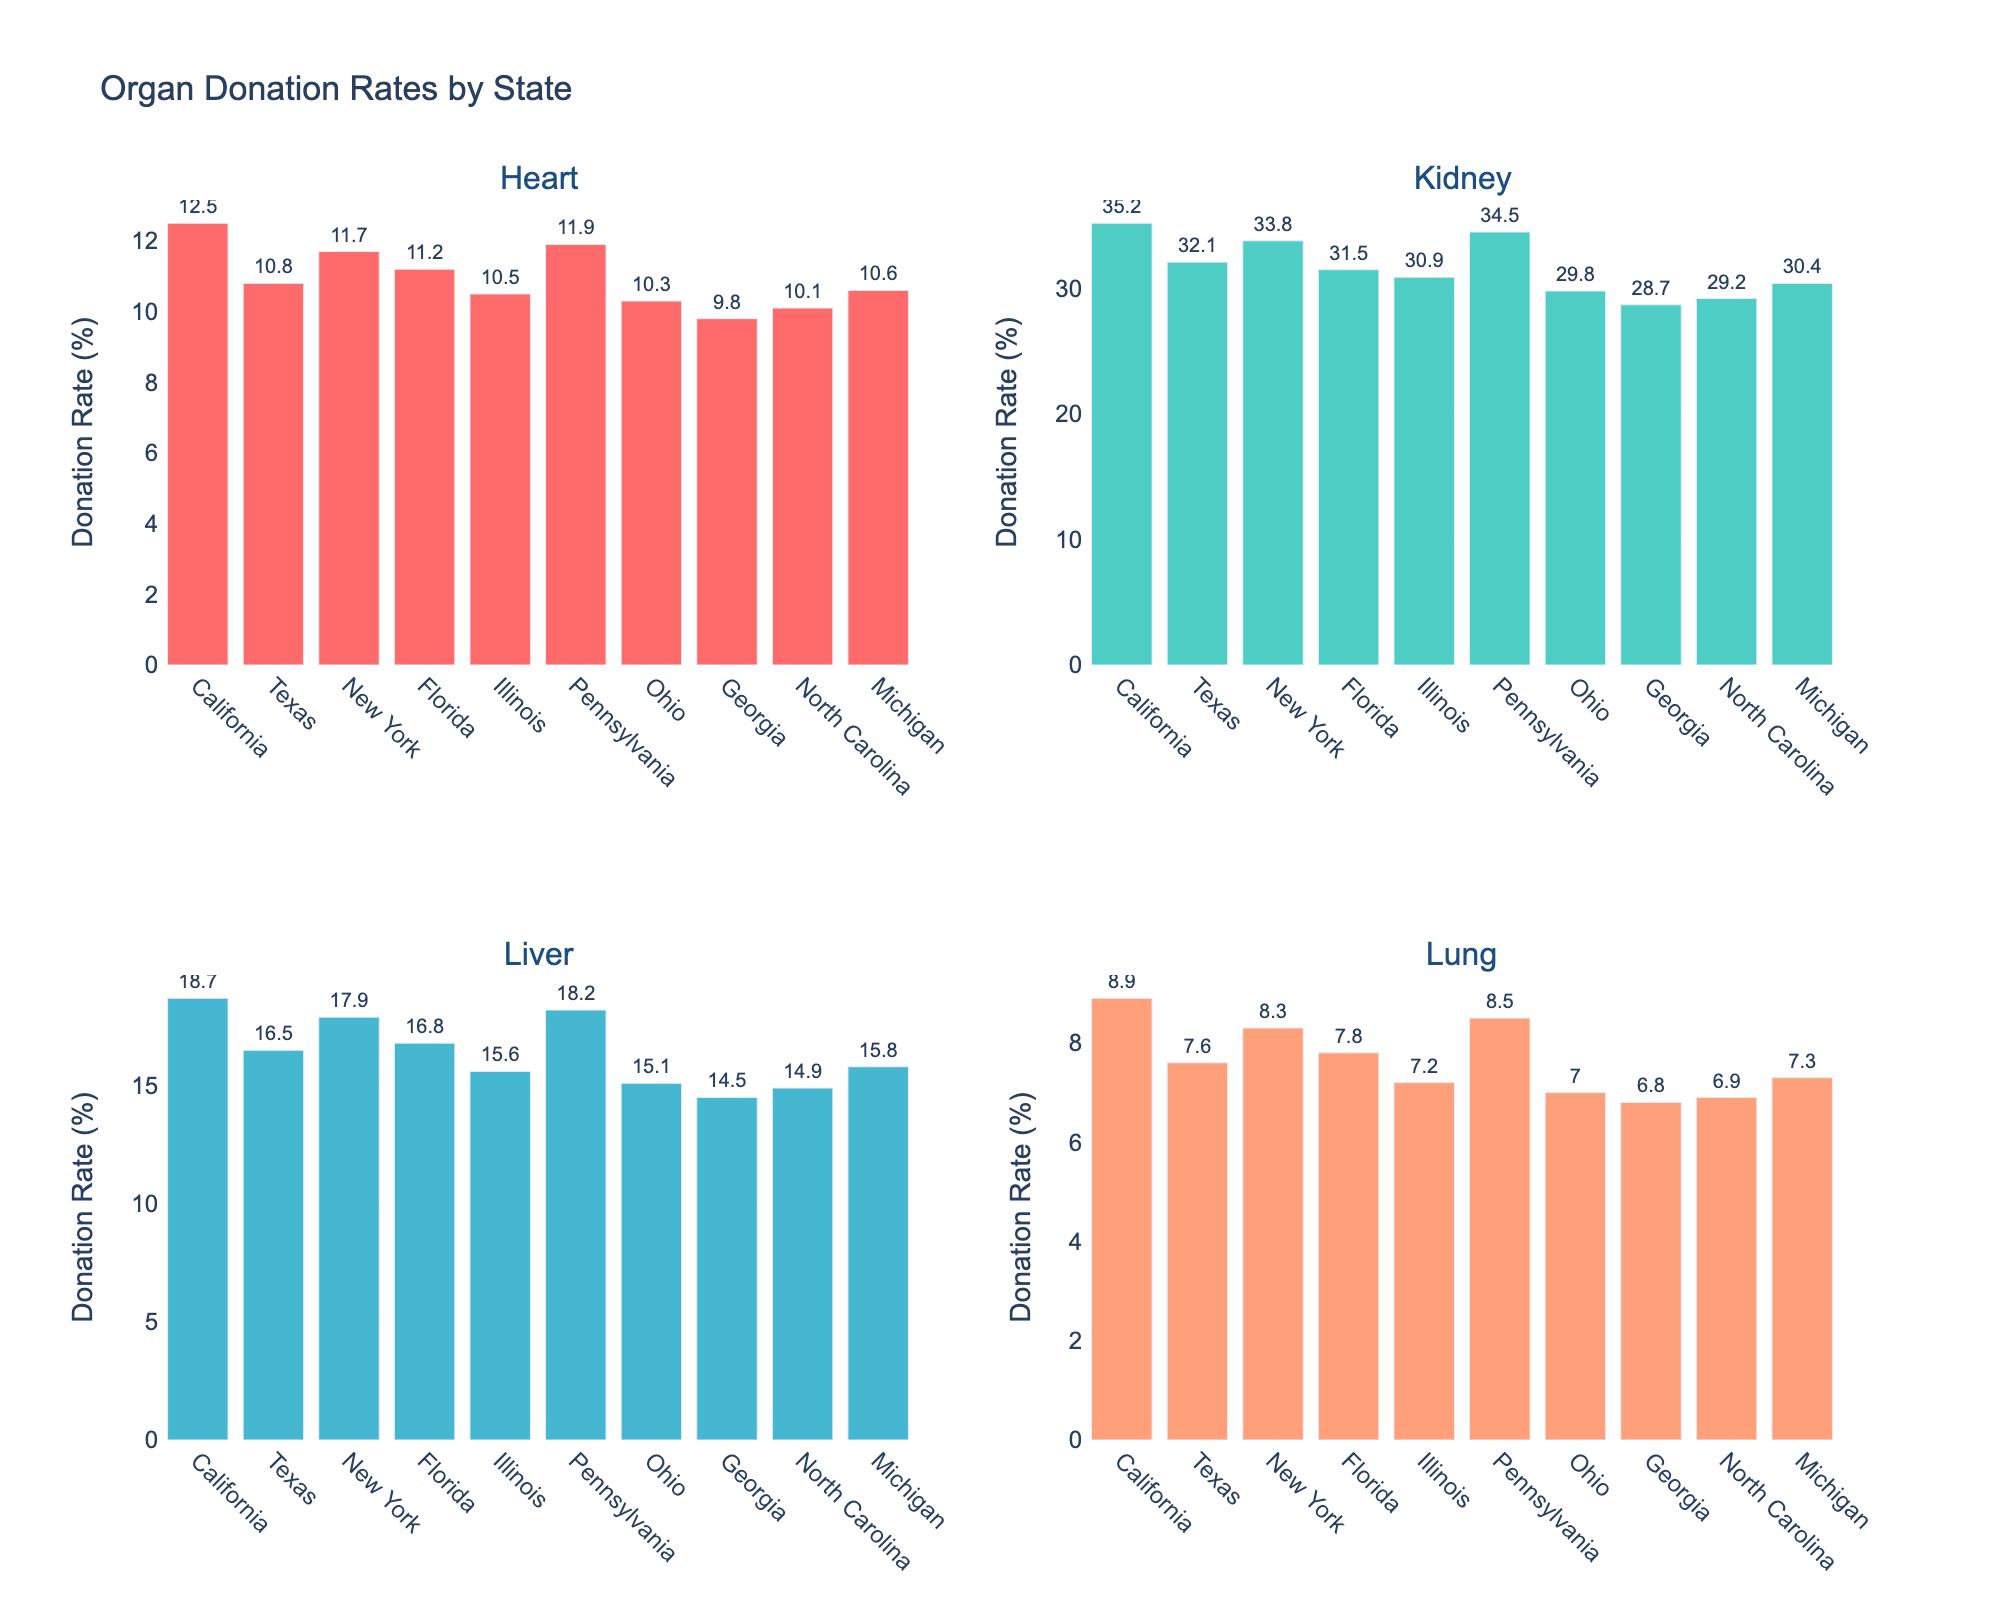What is the title of the figure? The title is usually displayed at the top of the figure. It is clearly indicated as "Attendance Trends at Major Civil Rights Rallies (1950s to Present)"
Answer: Attendance Trends at Major Civil Rights Rallies (1950s to Present) Which cause had the highest attendance in 2020? By looking at the y-values for the year 2020 across all subplots, it's apparent that the LGBTQ+ Rights rally had the highest attendance with a peak reaching 2,000,000
Answer: LGBTQ+ Rights How many causes are displayed in the figure? The figure is divided into four subplots, each representing a different cause: Civil Rights, Women's Rights, LGBTQ+ Rights, and Environmental Justice
Answer: Four What is the attendance trend for Civil Rights rallies from 1955 to 2020? By examining the plot for Civil Rights, we see that attendance starts at 20,000 in 1955, peaks at 250,000 in 1963, fluctuates over the years, and then rises steeply to 500,000 in 2020
Answer: Rapid increase then fluctuation Compare the attendance of Women's Rights rallies in 1975 and 2020. By observing the values on the y-axis for Women's Rights in both 1975 and 2020, it's clear that attendance was 100,000 in 1975 and significantly increased to 3,000,000 in 2020
Answer: Increased from 100,000 to 3,000,000 Which year had the lowest attendance for Environmental Justice rallies? By checking the lowest y-values in the Environmental Justice subplot, it's apparent that the year 1955 had the lowest attendance with just 500 attendees
Answer: 1955 In which cause did the attendance see a consistent and significant increase over the years? Analyzing all the subplots, we observe that the Women's Rights cause shows a consistent and significant increase, especially evident from 1975 onwards
Answer: Women's Rights How does the attendance of LGBTQ+ Rights rallies in 2000 compare to Civil Rights rallies in the same year? In the subplots, LGBTQ+ Rights in 2000 had 750,000 attendees, whereas Civil Rights had 100,000 attendees, indicating that LGBTQ+ Rights rallies had a significantly higher attendance that year
Answer: LGBTQ+ Rights had higher attendance What is the average attendance for Women's Rights rallies from 1993 to 2020? Summing the attendance values for the years 1993, 2000, 2008, 2015, and 2020 (80,000 + 500,000 + 750,000 + 1,000,000 + 3,000,000) gives 5,330,000. Dividing by the number of years (5) results in an average attendance of 1,066,000
Answer: 1,066,000 What are the maximum attendances recorded for each cause, and which year did they occur? By identifying the highest points in each subplot: Civil Rights (500,000 in 2020), Women's Rights (3,000,000 in 2020), LGBTQ+ Rights (2,000,000 in 2020), Environmental Justice (1,000,000 in 2020)
Answer: Civil Rights: 500,000 in 2020, Women's Rights: 3,000,000 in 2020, LGBTQ+ Rights: 2,000,000 in 2020, Environmental Justice: 1,000,000 in 2020 